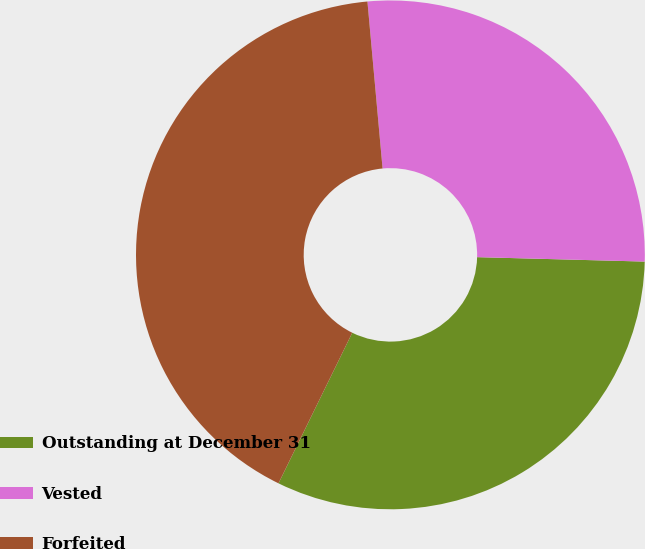Convert chart. <chart><loc_0><loc_0><loc_500><loc_500><pie_chart><fcel>Outstanding at December 31<fcel>Vested<fcel>Forfeited<nl><fcel>31.83%<fcel>26.86%<fcel>41.31%<nl></chart> 